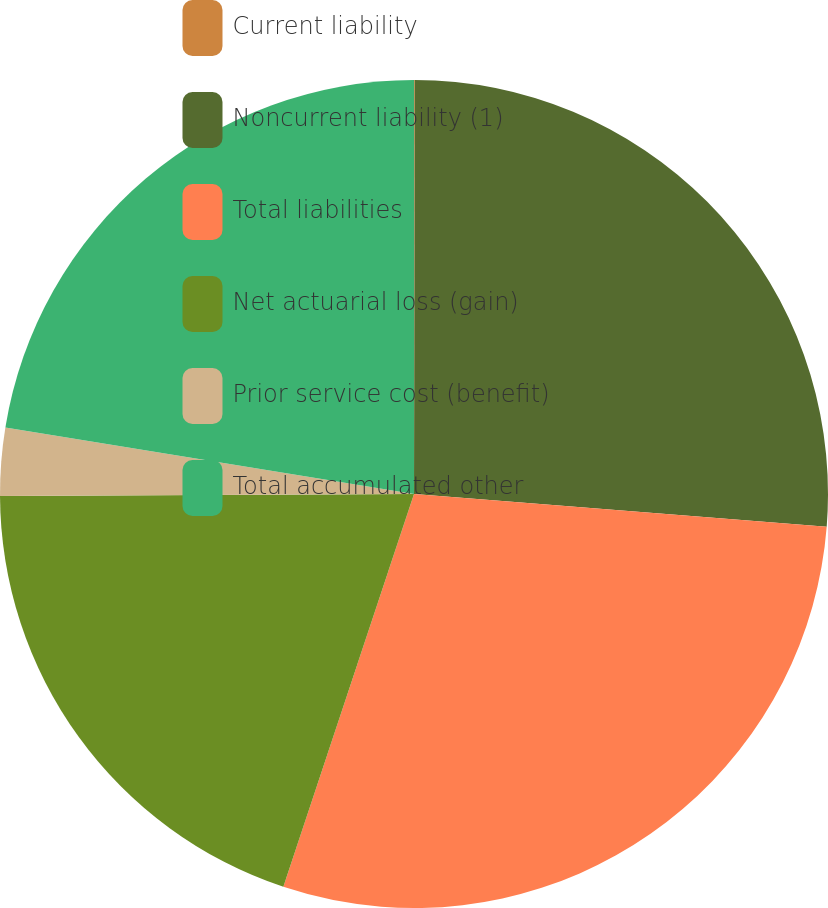Convert chart. <chart><loc_0><loc_0><loc_500><loc_500><pie_chart><fcel>Current liability<fcel>Noncurrent liability (1)<fcel>Total liabilities<fcel>Net actuarial loss (gain)<fcel>Prior service cost (benefit)<fcel>Total accumulated other<nl><fcel>0.03%<fcel>26.23%<fcel>28.85%<fcel>19.81%<fcel>2.65%<fcel>22.43%<nl></chart> 